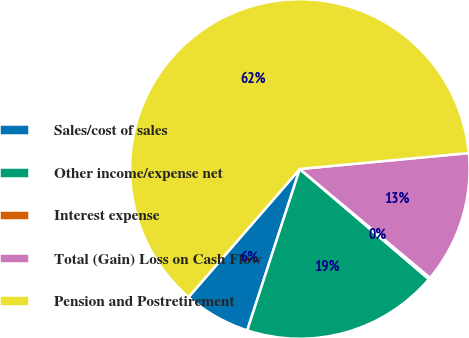<chart> <loc_0><loc_0><loc_500><loc_500><pie_chart><fcel>Sales/cost of sales<fcel>Other income/expense net<fcel>Interest expense<fcel>Total (Gain) Loss on Cash Flow<fcel>Pension and Postretirement<nl><fcel>6.37%<fcel>18.76%<fcel>0.18%<fcel>12.57%<fcel>62.12%<nl></chart> 